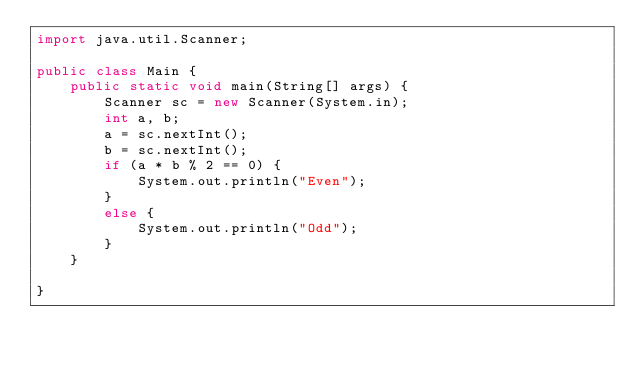<code> <loc_0><loc_0><loc_500><loc_500><_Java_>import java.util.Scanner;

public class Main {
	public static void main(String[] args) {
		Scanner sc = new Scanner(System.in);
		int a, b;
		a = sc.nextInt();
		b = sc.nextInt();
		if (a * b % 2 == 0) {
			System.out.println("Even");
		}
		else {
			System.out.println("Odd");
		}
	}

}
</code> 